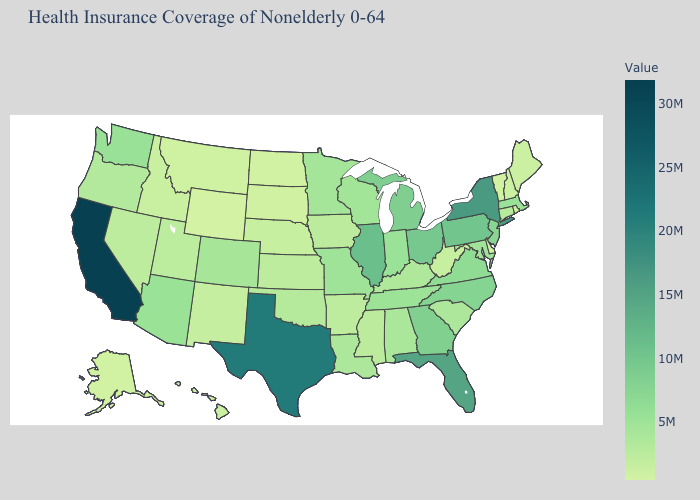Does Massachusetts have the highest value in the Northeast?
Quick response, please. No. Among the states that border New York , which have the lowest value?
Quick response, please. Vermont. Does the map have missing data?
Give a very brief answer. No. Does the map have missing data?
Be succinct. No. Among the states that border North Carolina , which have the highest value?
Keep it brief. Georgia. Which states have the lowest value in the Northeast?
Quick response, please. Vermont. Does Vermont have the lowest value in the Northeast?
Quick response, please. Yes. Does North Dakota have the lowest value in the MidWest?
Answer briefly. Yes. 